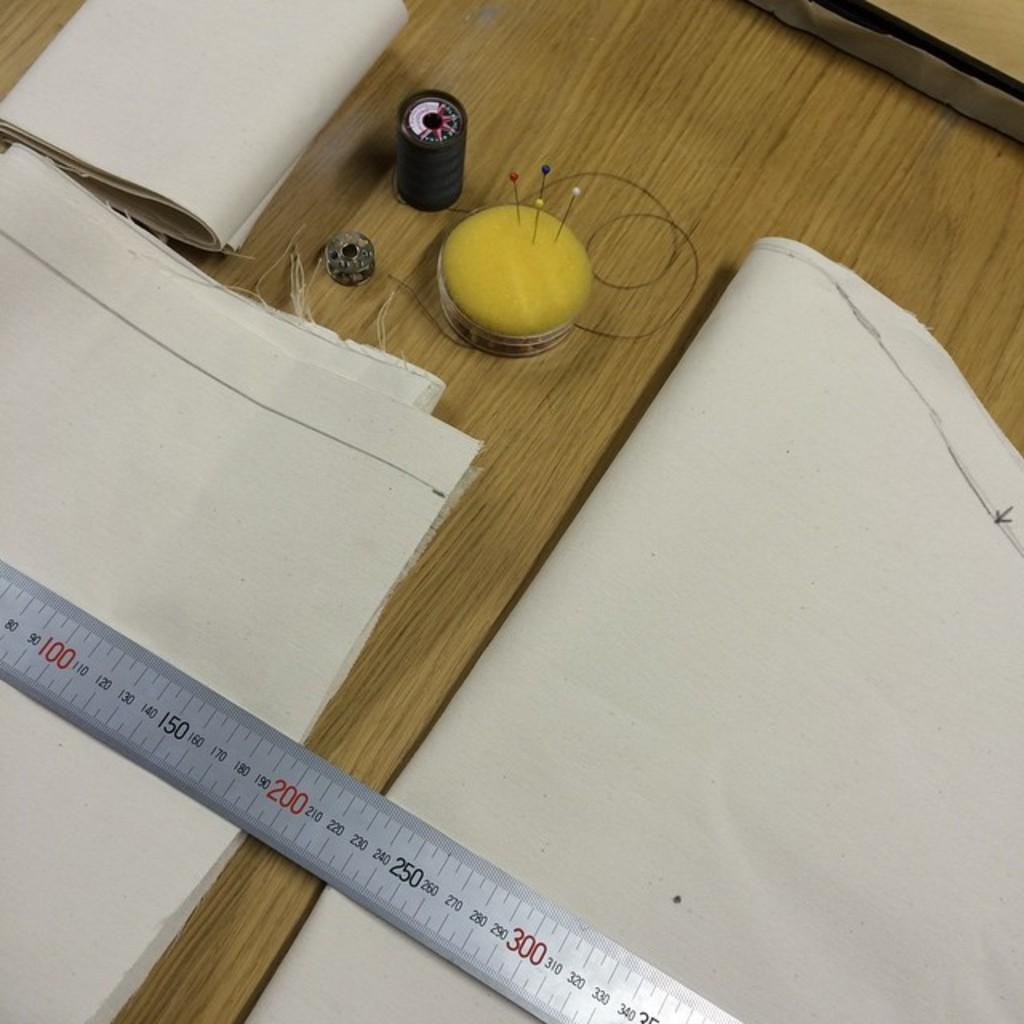Provide a one-sentence caption for the provided image. 200 centi meters of fabric are being measured. 